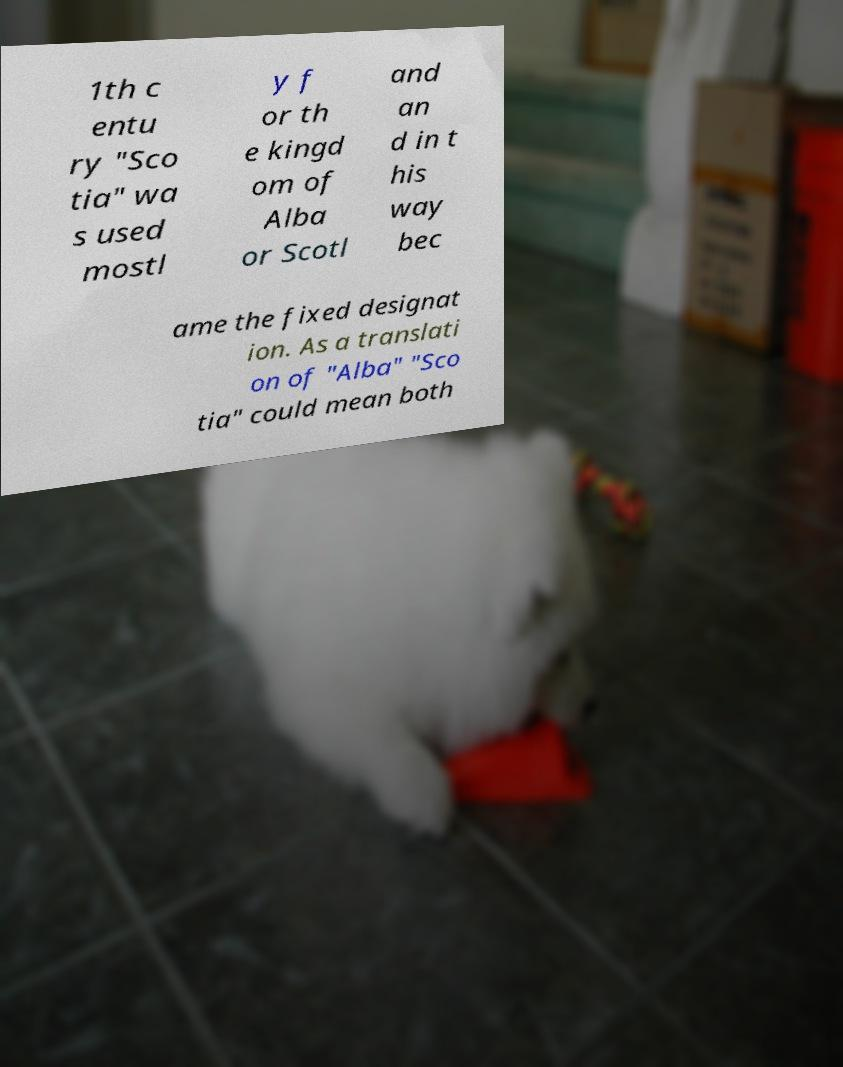Could you assist in decoding the text presented in this image and type it out clearly? 1th c entu ry "Sco tia" wa s used mostl y f or th e kingd om of Alba or Scotl and an d in t his way bec ame the fixed designat ion. As a translati on of "Alba" "Sco tia" could mean both 